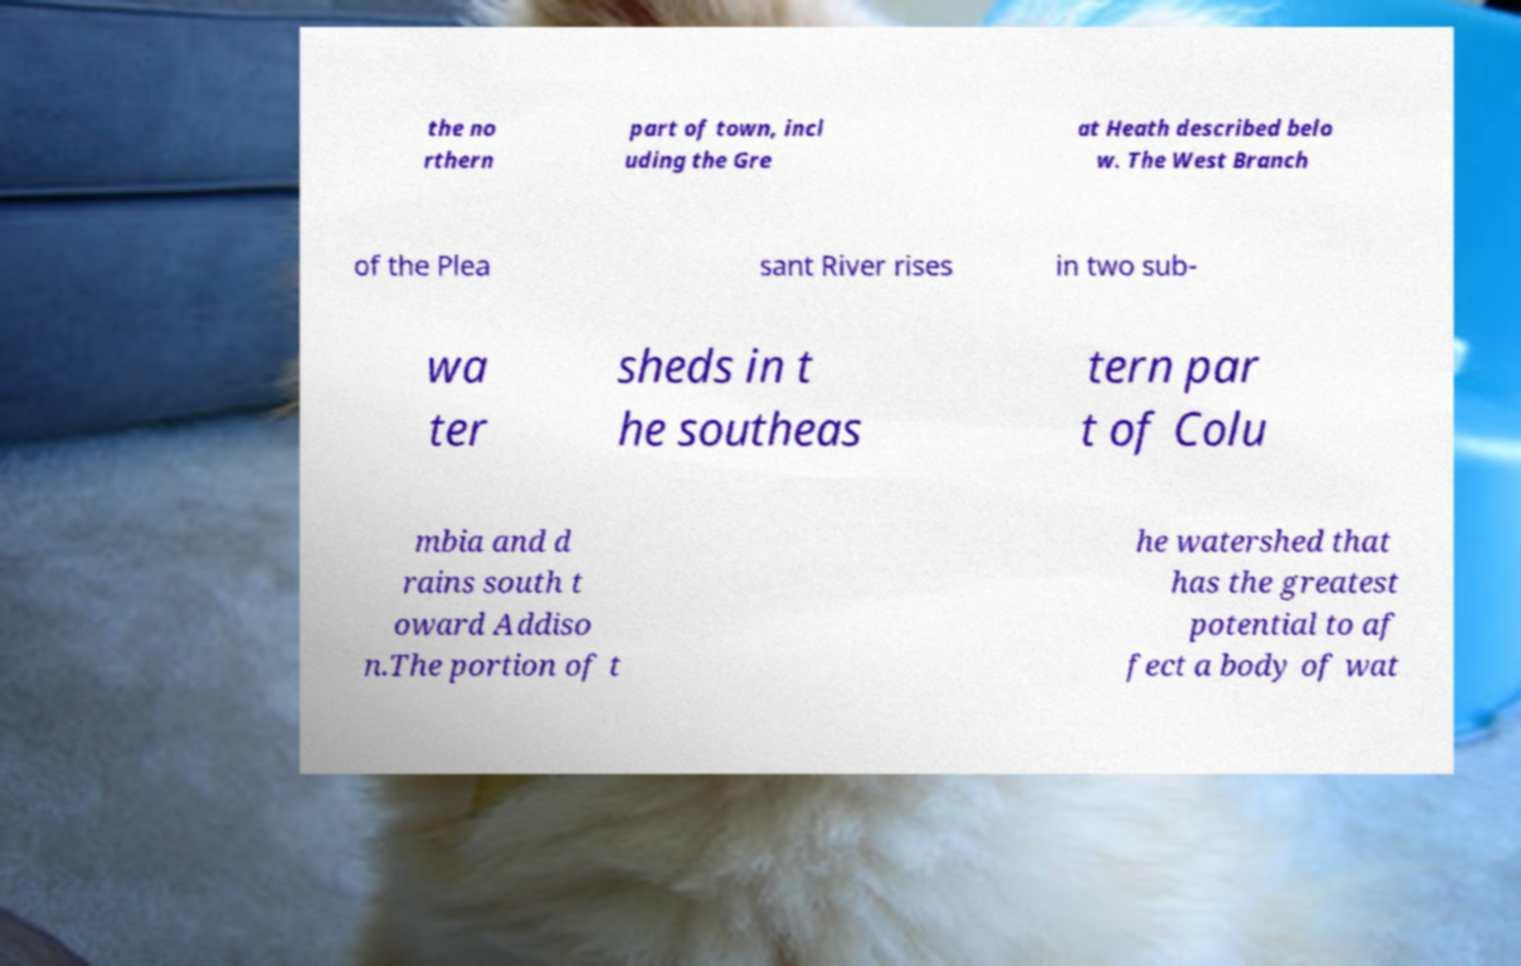I need the written content from this picture converted into text. Can you do that? the no rthern part of town, incl uding the Gre at Heath described belo w. The West Branch of the Plea sant River rises in two sub- wa ter sheds in t he southeas tern par t of Colu mbia and d rains south t oward Addiso n.The portion of t he watershed that has the greatest potential to af fect a body of wat 